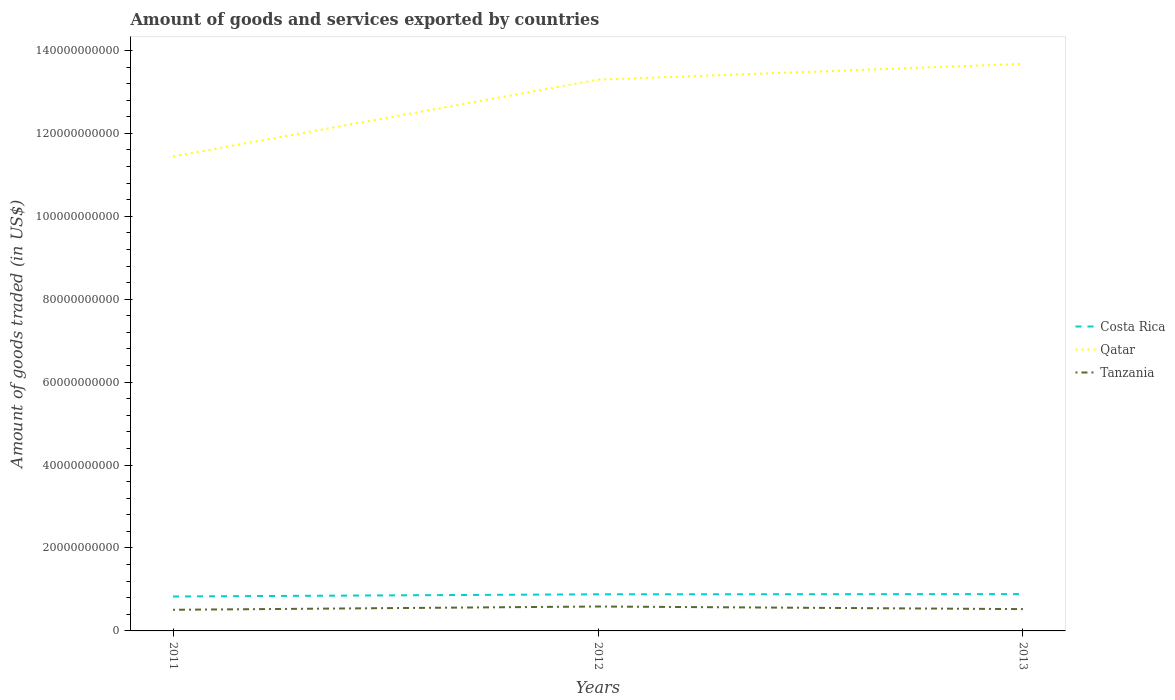How many different coloured lines are there?
Ensure brevity in your answer.  3. Does the line corresponding to Costa Rica intersect with the line corresponding to Tanzania?
Give a very brief answer. No. Is the number of lines equal to the number of legend labels?
Ensure brevity in your answer.  Yes. Across all years, what is the maximum total amount of goods and services exported in Costa Rica?
Your response must be concise. 8.30e+09. What is the total total amount of goods and services exported in Qatar in the graph?
Offer a terse response. -1.85e+1. What is the difference between the highest and the second highest total amount of goods and services exported in Tanzania?
Your answer should be compact. 7.91e+08. Is the total amount of goods and services exported in Tanzania strictly greater than the total amount of goods and services exported in Costa Rica over the years?
Offer a terse response. Yes. How many years are there in the graph?
Your answer should be compact. 3. What is the difference between two consecutive major ticks on the Y-axis?
Provide a short and direct response. 2.00e+1. Does the graph contain any zero values?
Your response must be concise. No. Does the graph contain grids?
Make the answer very short. No. What is the title of the graph?
Ensure brevity in your answer.  Amount of goods and services exported by countries. Does "Latvia" appear as one of the legend labels in the graph?
Offer a very short reply. No. What is the label or title of the Y-axis?
Ensure brevity in your answer.  Amount of goods traded (in US$). What is the Amount of goods traded (in US$) of Costa Rica in 2011?
Provide a succinct answer. 8.30e+09. What is the Amount of goods traded (in US$) of Qatar in 2011?
Your answer should be very brief. 1.14e+11. What is the Amount of goods traded (in US$) in Tanzania in 2011?
Ensure brevity in your answer.  5.10e+09. What is the Amount of goods traded (in US$) of Costa Rica in 2012?
Provide a succinct answer. 8.83e+09. What is the Amount of goods traded (in US$) of Qatar in 2012?
Offer a very short reply. 1.33e+11. What is the Amount of goods traded (in US$) of Tanzania in 2012?
Keep it short and to the point. 5.89e+09. What is the Amount of goods traded (in US$) in Costa Rica in 2013?
Give a very brief answer. 8.88e+09. What is the Amount of goods traded (in US$) of Qatar in 2013?
Make the answer very short. 1.37e+11. What is the Amount of goods traded (in US$) in Tanzania in 2013?
Offer a terse response. 5.26e+09. Across all years, what is the maximum Amount of goods traded (in US$) in Costa Rica?
Provide a succinct answer. 8.88e+09. Across all years, what is the maximum Amount of goods traded (in US$) in Qatar?
Your answer should be very brief. 1.37e+11. Across all years, what is the maximum Amount of goods traded (in US$) in Tanzania?
Your answer should be compact. 5.89e+09. Across all years, what is the minimum Amount of goods traded (in US$) in Costa Rica?
Make the answer very short. 8.30e+09. Across all years, what is the minimum Amount of goods traded (in US$) of Qatar?
Your answer should be very brief. 1.14e+11. Across all years, what is the minimum Amount of goods traded (in US$) of Tanzania?
Make the answer very short. 5.10e+09. What is the total Amount of goods traded (in US$) of Costa Rica in the graph?
Offer a very short reply. 2.60e+1. What is the total Amount of goods traded (in US$) of Qatar in the graph?
Offer a terse response. 3.84e+11. What is the total Amount of goods traded (in US$) in Tanzania in the graph?
Provide a short and direct response. 1.62e+1. What is the difference between the Amount of goods traded (in US$) of Costa Rica in 2011 and that in 2012?
Make the answer very short. -5.29e+08. What is the difference between the Amount of goods traded (in US$) in Qatar in 2011 and that in 2012?
Offer a very short reply. -1.85e+1. What is the difference between the Amount of goods traded (in US$) of Tanzania in 2011 and that in 2012?
Provide a short and direct response. -7.91e+08. What is the difference between the Amount of goods traded (in US$) in Costa Rica in 2011 and that in 2013?
Your response must be concise. -5.75e+08. What is the difference between the Amount of goods traded (in US$) in Qatar in 2011 and that in 2013?
Give a very brief answer. -2.23e+1. What is the difference between the Amount of goods traded (in US$) in Tanzania in 2011 and that in 2013?
Offer a terse response. -1.60e+08. What is the difference between the Amount of goods traded (in US$) in Costa Rica in 2012 and that in 2013?
Make the answer very short. -4.57e+07. What is the difference between the Amount of goods traded (in US$) in Qatar in 2012 and that in 2013?
Your answer should be very brief. -3.81e+09. What is the difference between the Amount of goods traded (in US$) in Tanzania in 2012 and that in 2013?
Provide a short and direct response. 6.31e+08. What is the difference between the Amount of goods traded (in US$) in Costa Rica in 2011 and the Amount of goods traded (in US$) in Qatar in 2012?
Your answer should be very brief. -1.25e+11. What is the difference between the Amount of goods traded (in US$) in Costa Rica in 2011 and the Amount of goods traded (in US$) in Tanzania in 2012?
Your response must be concise. 2.41e+09. What is the difference between the Amount of goods traded (in US$) in Qatar in 2011 and the Amount of goods traded (in US$) in Tanzania in 2012?
Your answer should be compact. 1.09e+11. What is the difference between the Amount of goods traded (in US$) in Costa Rica in 2011 and the Amount of goods traded (in US$) in Qatar in 2013?
Your answer should be very brief. -1.28e+11. What is the difference between the Amount of goods traded (in US$) of Costa Rica in 2011 and the Amount of goods traded (in US$) of Tanzania in 2013?
Offer a very short reply. 3.05e+09. What is the difference between the Amount of goods traded (in US$) of Qatar in 2011 and the Amount of goods traded (in US$) of Tanzania in 2013?
Ensure brevity in your answer.  1.09e+11. What is the difference between the Amount of goods traded (in US$) in Costa Rica in 2012 and the Amount of goods traded (in US$) in Qatar in 2013?
Your answer should be compact. -1.28e+11. What is the difference between the Amount of goods traded (in US$) in Costa Rica in 2012 and the Amount of goods traded (in US$) in Tanzania in 2013?
Provide a short and direct response. 3.58e+09. What is the difference between the Amount of goods traded (in US$) in Qatar in 2012 and the Amount of goods traded (in US$) in Tanzania in 2013?
Keep it short and to the point. 1.28e+11. What is the average Amount of goods traded (in US$) in Costa Rica per year?
Offer a very short reply. 8.67e+09. What is the average Amount of goods traded (in US$) in Qatar per year?
Your answer should be compact. 1.28e+11. What is the average Amount of goods traded (in US$) in Tanzania per year?
Keep it short and to the point. 5.42e+09. In the year 2011, what is the difference between the Amount of goods traded (in US$) of Costa Rica and Amount of goods traded (in US$) of Qatar?
Provide a short and direct response. -1.06e+11. In the year 2011, what is the difference between the Amount of goods traded (in US$) in Costa Rica and Amount of goods traded (in US$) in Tanzania?
Keep it short and to the point. 3.21e+09. In the year 2011, what is the difference between the Amount of goods traded (in US$) of Qatar and Amount of goods traded (in US$) of Tanzania?
Provide a short and direct response. 1.09e+11. In the year 2012, what is the difference between the Amount of goods traded (in US$) of Costa Rica and Amount of goods traded (in US$) of Qatar?
Give a very brief answer. -1.24e+11. In the year 2012, what is the difference between the Amount of goods traded (in US$) in Costa Rica and Amount of goods traded (in US$) in Tanzania?
Your answer should be very brief. 2.94e+09. In the year 2012, what is the difference between the Amount of goods traded (in US$) of Qatar and Amount of goods traded (in US$) of Tanzania?
Ensure brevity in your answer.  1.27e+11. In the year 2013, what is the difference between the Amount of goods traded (in US$) of Costa Rica and Amount of goods traded (in US$) of Qatar?
Your response must be concise. -1.28e+11. In the year 2013, what is the difference between the Amount of goods traded (in US$) of Costa Rica and Amount of goods traded (in US$) of Tanzania?
Offer a very short reply. 3.62e+09. In the year 2013, what is the difference between the Amount of goods traded (in US$) in Qatar and Amount of goods traded (in US$) in Tanzania?
Offer a terse response. 1.32e+11. What is the ratio of the Amount of goods traded (in US$) of Costa Rica in 2011 to that in 2012?
Ensure brevity in your answer.  0.94. What is the ratio of the Amount of goods traded (in US$) of Qatar in 2011 to that in 2012?
Make the answer very short. 0.86. What is the ratio of the Amount of goods traded (in US$) of Tanzania in 2011 to that in 2012?
Keep it short and to the point. 0.87. What is the ratio of the Amount of goods traded (in US$) in Costa Rica in 2011 to that in 2013?
Ensure brevity in your answer.  0.94. What is the ratio of the Amount of goods traded (in US$) in Qatar in 2011 to that in 2013?
Provide a short and direct response. 0.84. What is the ratio of the Amount of goods traded (in US$) of Tanzania in 2011 to that in 2013?
Make the answer very short. 0.97. What is the ratio of the Amount of goods traded (in US$) of Qatar in 2012 to that in 2013?
Provide a succinct answer. 0.97. What is the ratio of the Amount of goods traded (in US$) of Tanzania in 2012 to that in 2013?
Make the answer very short. 1.12. What is the difference between the highest and the second highest Amount of goods traded (in US$) in Costa Rica?
Your answer should be compact. 4.57e+07. What is the difference between the highest and the second highest Amount of goods traded (in US$) in Qatar?
Provide a short and direct response. 3.81e+09. What is the difference between the highest and the second highest Amount of goods traded (in US$) of Tanzania?
Provide a succinct answer. 6.31e+08. What is the difference between the highest and the lowest Amount of goods traded (in US$) of Costa Rica?
Keep it short and to the point. 5.75e+08. What is the difference between the highest and the lowest Amount of goods traded (in US$) in Qatar?
Keep it short and to the point. 2.23e+1. What is the difference between the highest and the lowest Amount of goods traded (in US$) of Tanzania?
Provide a succinct answer. 7.91e+08. 